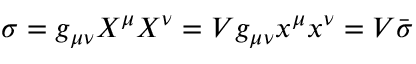<formula> <loc_0><loc_0><loc_500><loc_500>\sigma = g _ { \mu \nu } X ^ { \mu } X ^ { \nu } = V g _ { \mu \nu } x ^ { \mu } x ^ { \nu } = V { \bar { \sigma } }</formula> 